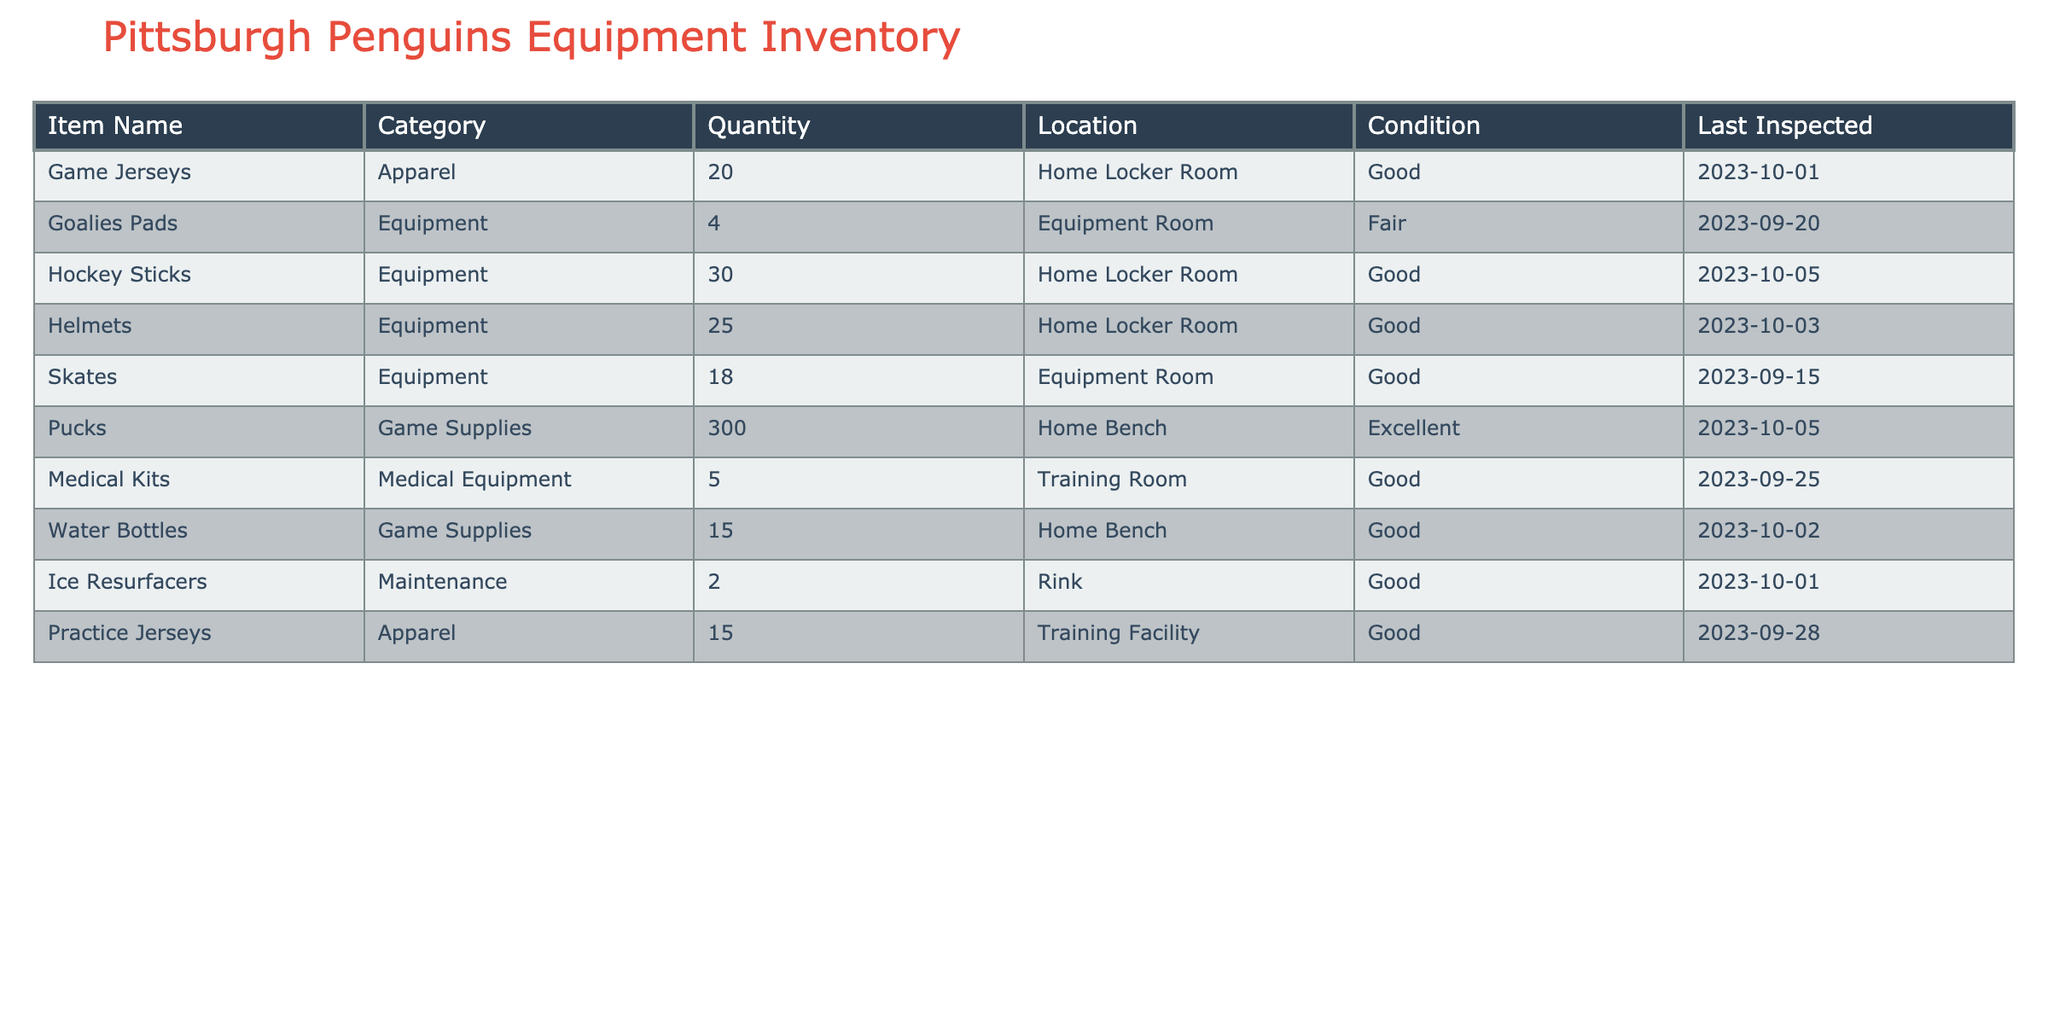What is the total number of Hockey Sticks in the inventory? There are 30 hockey sticks listed in the inventory under the Equipment category.
Answer: 30 What is the condition of the Goalies Pads? The Goalies Pads are marked as being in fair condition.
Answer: Fair Are there more Game Jerseys or Practice Jerseys? There are 20 Game Jerseys compared to 15 Practice Jerseys, so there are more Game Jerseys.
Answer: Yes How many Medical Kits were last inspected on or after October 1st, 2023? The Medical Kits were last inspected on September 25th, 2023, which is before October 1st, 2023. Therefore, none meet the criteria.
Answer: 0 What is the total number of Pucks and Water Bottles combined? The total number of Pucks is 300 and Water Bottles is 15. Therefore, the sum is 300 + 15 = 315.
Answer: 315 How many pieces of Equipment are in good condition? The Equipment items in good condition are Hockey Sticks (30), Helmets (25), and Skates (18). Summing these gives 30 + 25 + 18 = 73.
Answer: 73 What category does the item 'Ice Resurfacers' belong to? The Ice Resurfacers are categorized under Maintenance.
Answer: Maintenance Is there a sufficient quantity of Water Bottles for a game? With 15 Water Bottles in good condition, it may be insufficient for an entire team needing more than this during a game.
Answer: No How many items were last inspected in the month of September? The items inspected in September include Goalies Pads, Skates, Medical Kits, and Practice Jerseys. This counts up to four items.
Answer: 4 